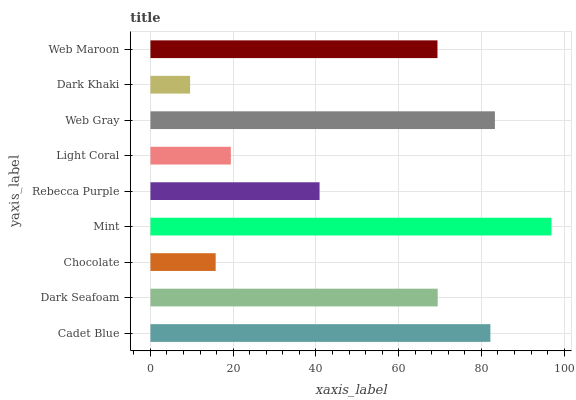Is Dark Khaki the minimum?
Answer yes or no. Yes. Is Mint the maximum?
Answer yes or no. Yes. Is Dark Seafoam the minimum?
Answer yes or no. No. Is Dark Seafoam the maximum?
Answer yes or no. No. Is Cadet Blue greater than Dark Seafoam?
Answer yes or no. Yes. Is Dark Seafoam less than Cadet Blue?
Answer yes or no. Yes. Is Dark Seafoam greater than Cadet Blue?
Answer yes or no. No. Is Cadet Blue less than Dark Seafoam?
Answer yes or no. No. Is Web Maroon the high median?
Answer yes or no. Yes. Is Web Maroon the low median?
Answer yes or no. Yes. Is Dark Khaki the high median?
Answer yes or no. No. Is Dark Khaki the low median?
Answer yes or no. No. 